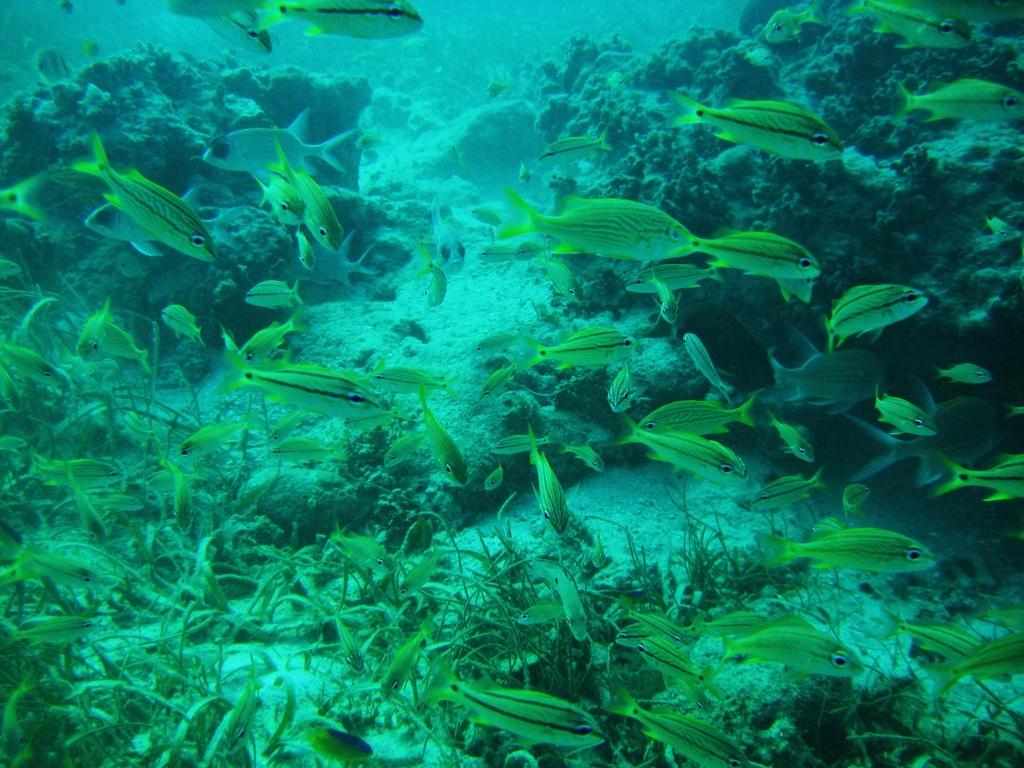What type of animals can be seen in the water in the image? There are fishes in the water in the image. What other objects can be seen in the water? There is: There is grass and corals in the water in the image. Where is the nearest store to the location of the image? There is no information about the location of the image or the nearest store, so it cannot be determined from the image. 